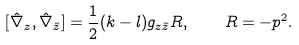<formula> <loc_0><loc_0><loc_500><loc_500>[ \hat { \nabla } _ { z } , \hat { \nabla } _ { \bar { z } } ] = \frac { 1 } { 2 } ( k - l ) g _ { z { \bar { z } } } R , \quad R = - p ^ { 2 } .</formula> 